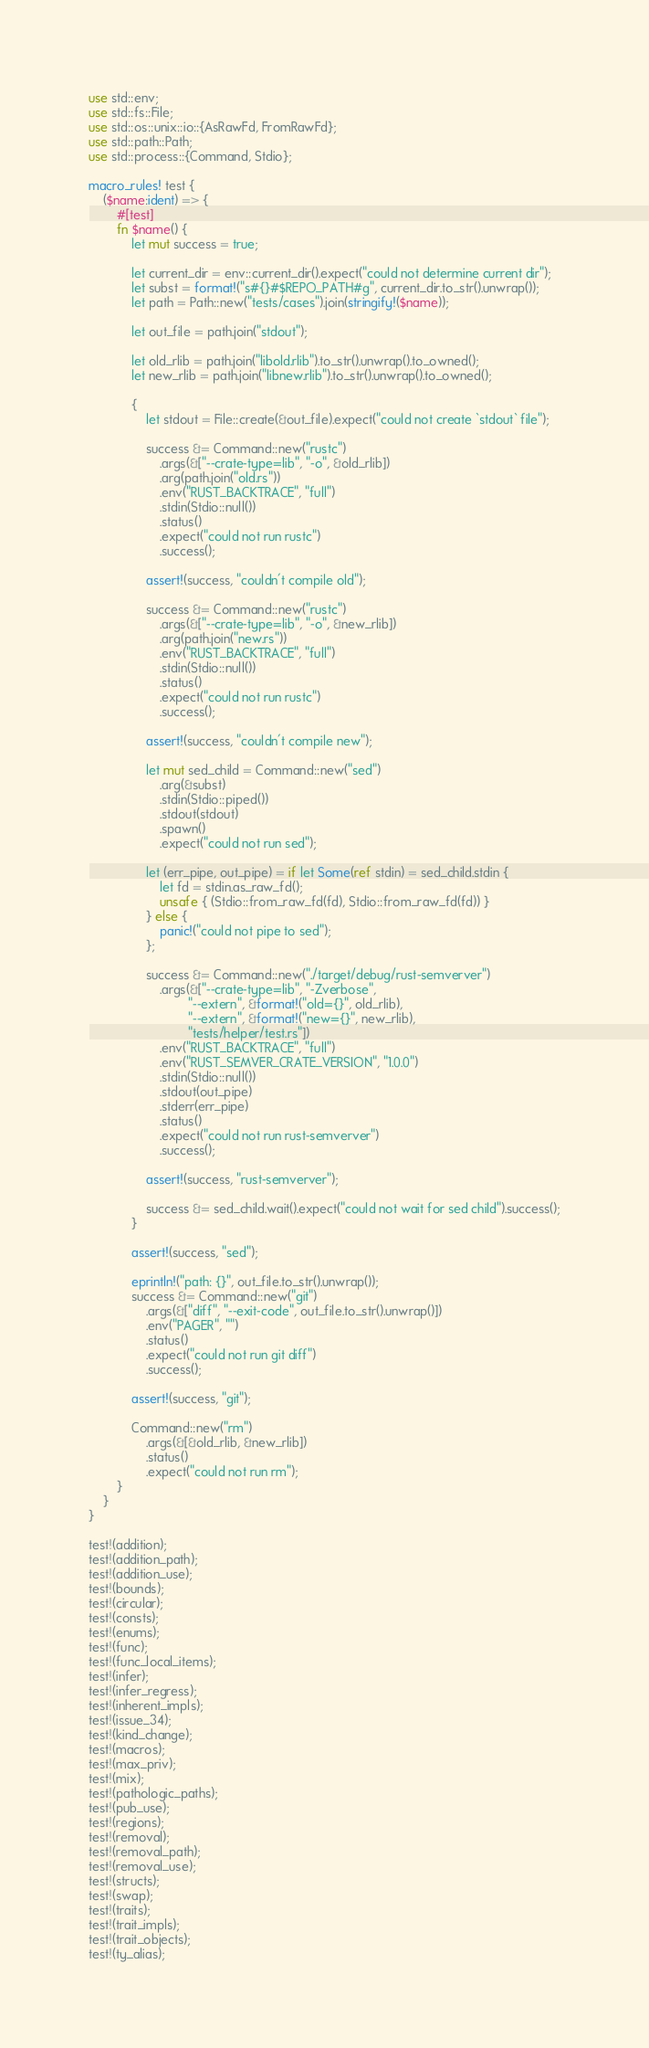Convert code to text. <code><loc_0><loc_0><loc_500><loc_500><_Rust_>use std::env;
use std::fs::File;
use std::os::unix::io::{AsRawFd, FromRawFd};
use std::path::Path;
use std::process::{Command, Stdio};

macro_rules! test {
    ($name:ident) => {
        #[test]
        fn $name() {
            let mut success = true;

            let current_dir = env::current_dir().expect("could not determine current dir");
            let subst = format!("s#{}#$REPO_PATH#g", current_dir.to_str().unwrap());
            let path = Path::new("tests/cases").join(stringify!($name));

            let out_file = path.join("stdout");

            let old_rlib = path.join("libold.rlib").to_str().unwrap().to_owned();
            let new_rlib = path.join("libnew.rlib").to_str().unwrap().to_owned();

            {
                let stdout = File::create(&out_file).expect("could not create `stdout` file");

                success &= Command::new("rustc")
                    .args(&["--crate-type=lib", "-o", &old_rlib])
                    .arg(path.join("old.rs"))
                    .env("RUST_BACKTRACE", "full")
                    .stdin(Stdio::null())
                    .status()
                    .expect("could not run rustc")
                    .success();

                assert!(success, "couldn't compile old");

                success &= Command::new("rustc")
                    .args(&["--crate-type=lib", "-o", &new_rlib])
                    .arg(path.join("new.rs"))
                    .env("RUST_BACKTRACE", "full")
                    .stdin(Stdio::null())
                    .status()
                    .expect("could not run rustc")
                    .success();

                assert!(success, "couldn't compile new");

                let mut sed_child = Command::new("sed")
                    .arg(&subst)
                    .stdin(Stdio::piped())
                    .stdout(stdout)
                    .spawn()
                    .expect("could not run sed");

                let (err_pipe, out_pipe) = if let Some(ref stdin) = sed_child.stdin {
                    let fd = stdin.as_raw_fd();
                    unsafe { (Stdio::from_raw_fd(fd), Stdio::from_raw_fd(fd)) }
                } else {
                    panic!("could not pipe to sed");
                };

                success &= Command::new("./target/debug/rust-semverver")
                    .args(&["--crate-type=lib", "-Zverbose",
                            "--extern", &format!("old={}", old_rlib),
                            "--extern", &format!("new={}", new_rlib),
                            "tests/helper/test.rs"])
                    .env("RUST_BACKTRACE", "full")
                    .env("RUST_SEMVER_CRATE_VERSION", "1.0.0")
                    .stdin(Stdio::null())
                    .stdout(out_pipe)
                    .stderr(err_pipe)
                    .status()
                    .expect("could not run rust-semverver")
                    .success();

                assert!(success, "rust-semverver");

                success &= sed_child.wait().expect("could not wait for sed child").success();
            }

            assert!(success, "sed");

            eprintln!("path: {}", out_file.to_str().unwrap());
            success &= Command::new("git")
                .args(&["diff", "--exit-code", out_file.to_str().unwrap()])
                .env("PAGER", "")
                .status()
                .expect("could not run git diff")
                .success();

            assert!(success, "git");

            Command::new("rm")
                .args(&[&old_rlib, &new_rlib])
                .status()
                .expect("could not run rm");
        }
    }
}

test!(addition);
test!(addition_path);
test!(addition_use);
test!(bounds);
test!(circular);
test!(consts);
test!(enums);
test!(func);
test!(func_local_items);
test!(infer);
test!(infer_regress);
test!(inherent_impls);
test!(issue_34);
test!(kind_change);
test!(macros);
test!(max_priv);
test!(mix);
test!(pathologic_paths);
test!(pub_use);
test!(regions);
test!(removal);
test!(removal_path);
test!(removal_use);
test!(structs);
test!(swap);
test!(traits);
test!(trait_impls);
test!(trait_objects);
test!(ty_alias);
</code> 